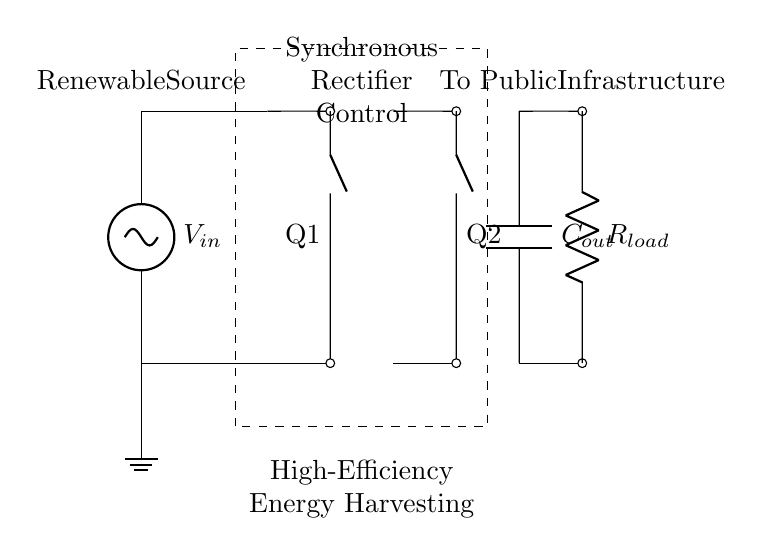What is the input voltage in this circuit? The circuit indicates a voltage source labeled as V_in, suggesting that it serves as the input voltage for the synchronous rectifier configuration.
Answer: V_in What components are used in the synchronous rectifier? The circuit diagram shows two components labeled Q1 and Q2, which are most likely MOSFETs functioning as switches in the synchronous rectifier setup.
Answer: Q1, Q2 How many capacitors are in this circuit? The diagram includes one capacitor labeled C_out, denoting the output stage of the rectifier.
Answer: One What is the primary function of the control section in this circuit? The control section, labeled as Synchronous Rectifier Control, manages the gate signals for Q1 and Q2, ensuring that the rectifier operates efficiently by minimizing conduction losses.
Answer: Manage gate signals Why are there two switches in this synchronous rectifier design? The two switches (Q1 and Q2) enable bidirectional current flow and enhance conduction efficiency by allowing the rectifier to adapt to both halves of the input AC waveform, thereby reducing energy loss during rectification.
Answer: Bidirectional current flow What type of energy harvesting does this circuit facilitate? The circuit is designed for high-efficiency energy harvesting from renewable sources, as indicated by the label next to the renewable source in the diagram.
Answer: Renewable energy 